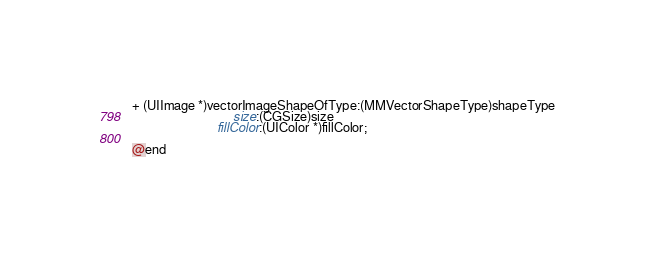Convert code to text. <code><loc_0><loc_0><loc_500><loc_500><_C_>+ (UIImage *)vectorImageShapeOfType:(MMVectorShapeType)shapeType
                               size:(CGSize)size
                          fillColor:(UIColor *)fillColor;

@end
</code> 